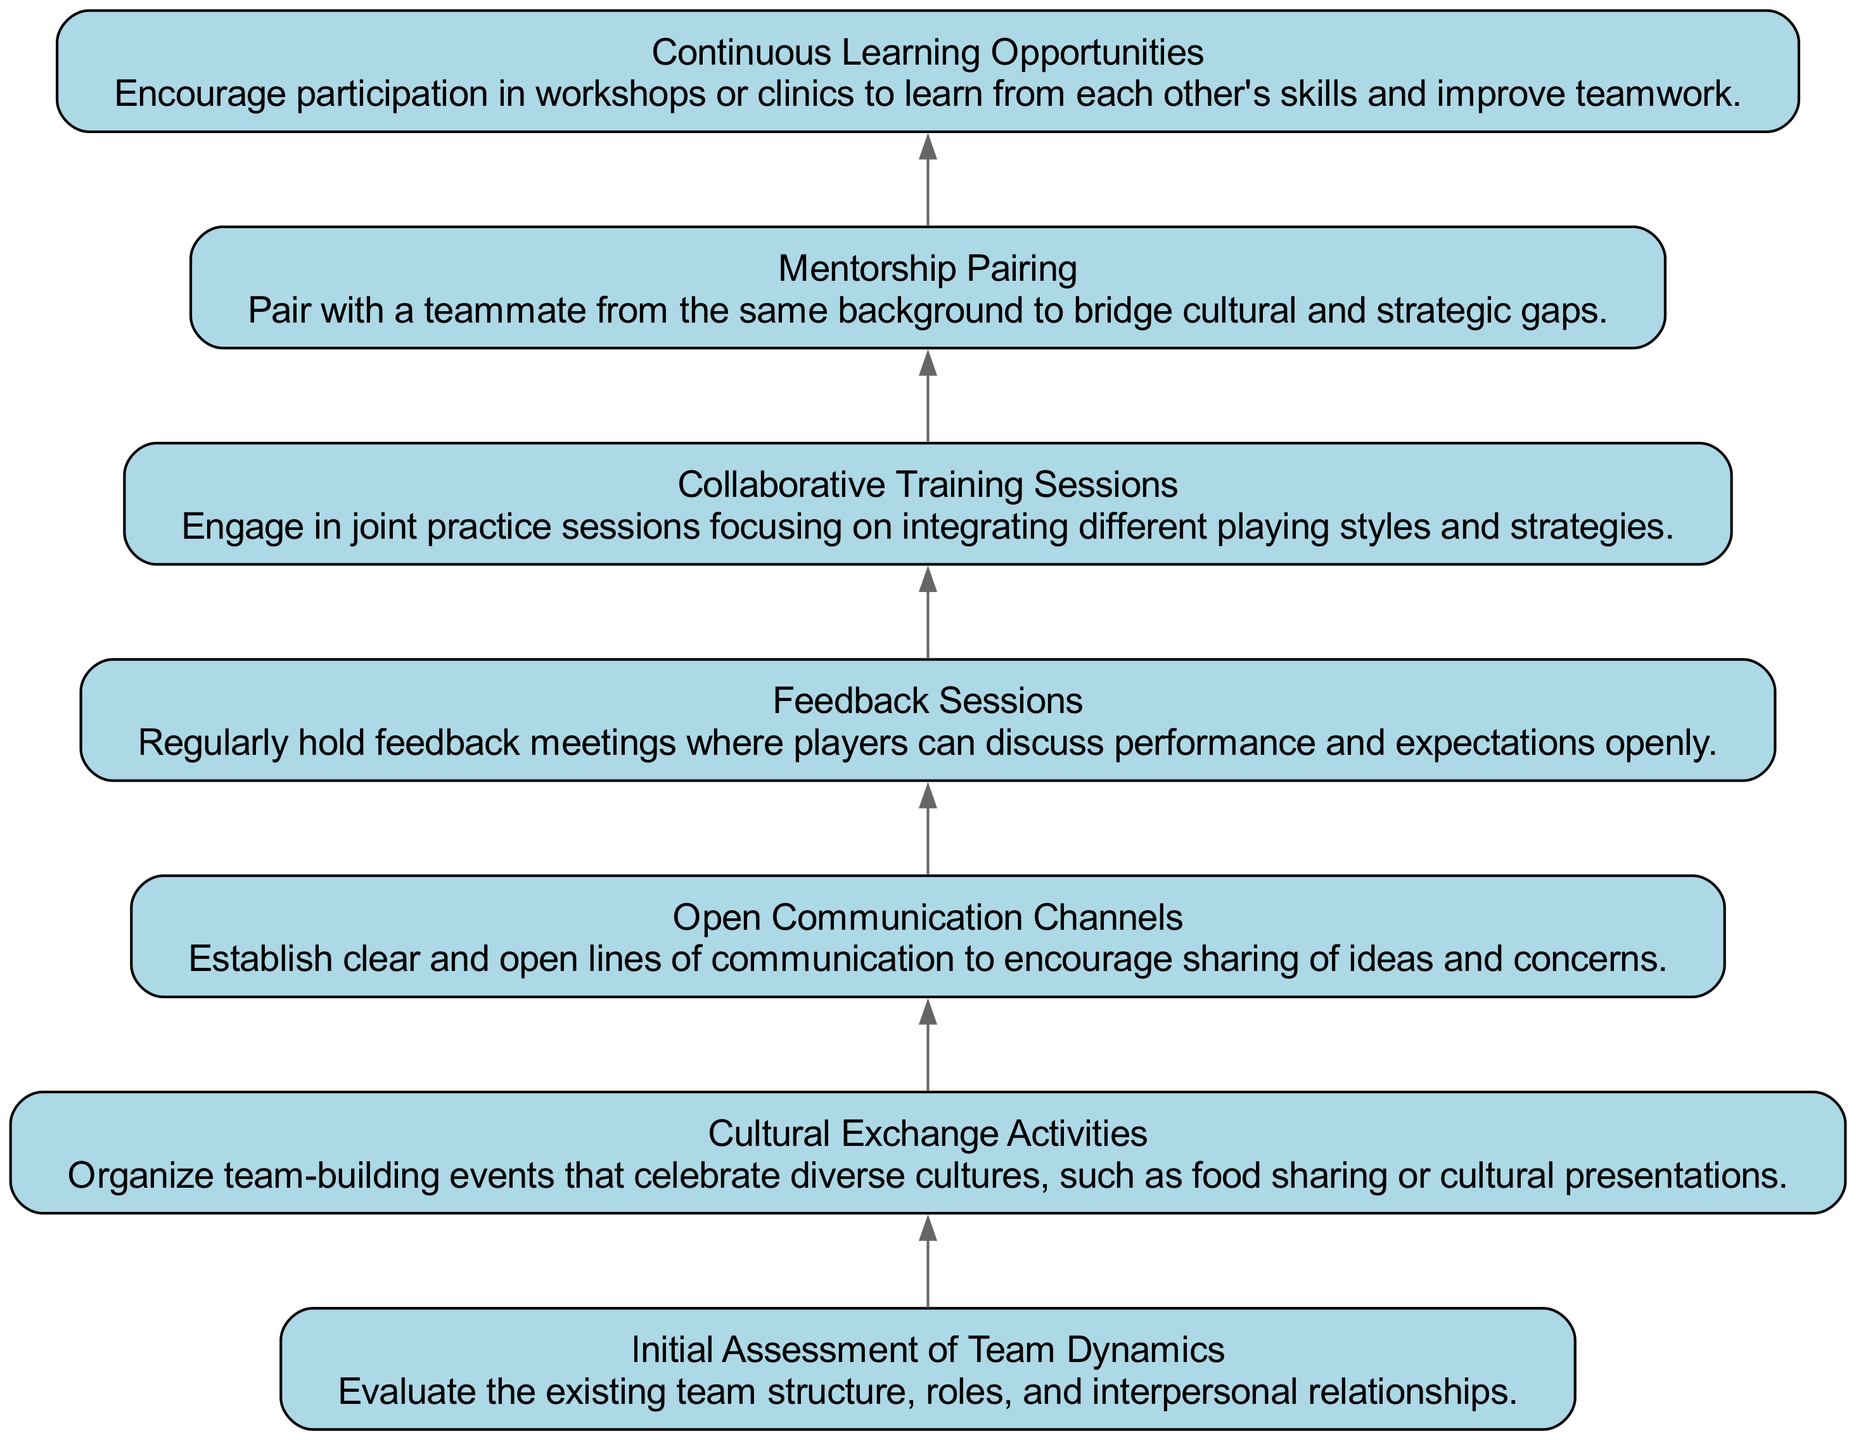What is the first step in the diagram? The first step in the diagram is "Initial Assessment of Team Dynamics," which evaluates the existing team structure, roles, and interpersonal relationships.
Answer: Initial Assessment of Team Dynamics How many nodes are present in the flow chart? The flow chart consists of 7 nodes, each representing a different strategy or step in the adaptation process.
Answer: 7 What step follows "Cultural Exchange Activities"? The step that follows "Cultural Exchange Activities" is "Open Communication Channels," where lines of communication are established.
Answer: Open Communication Channels Which step emphasizes training together? The step that emphasizes training together is "Collaborative Training Sessions," which focuses on integrating different playing styles and strategies during joint practice.
Answer: Collaborative Training Sessions What step encourages giving and receiving feedback? The step that encourages giving and receiving feedback is "Feedback Sessions," which regularly hold meetings for discussing performance and expectations openly.
Answer: Feedback Sessions What is the purpose of "Mentorship Pairing"? The purpose of "Mentorship Pairing" is to pair with a teammate from the same background to bridge cultural and strategic gaps, enhancing integration.
Answer: To bridge cultural and strategic gaps What is the last step in the diagram? The last step in the diagram is "Continuous Learning Opportunities," which encourages participation in workshops or clinics for skill improvement and better teamwork.
Answer: Continuous Learning Opportunities Which strategies promote cultural understanding? The strategies that promote cultural understanding are "Cultural Exchange Activities" and "Mentorship Pairing," as they focus on sharing cultural experiences and bridging backgrounds.
Answer: Cultural Exchange Activities, Mentorship Pairing 